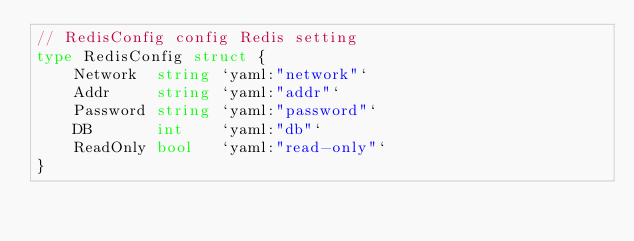<code> <loc_0><loc_0><loc_500><loc_500><_Go_>// RedisConfig config Redis setting
type RedisConfig struct {
	Network  string `yaml:"network"`
	Addr     string `yaml:"addr"`
	Password string `yaml:"password"`
	DB       int    `yaml:"db"`
	ReadOnly bool   `yaml:"read-only"`
}
</code> 